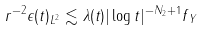<formula> <loc_0><loc_0><loc_500><loc_500>\| r ^ { - 2 } \epsilon ( t ) \| _ { L ^ { 2 } } \lesssim \lambda ( t ) | \log t | ^ { - N _ { 2 } + 1 } \| f \| _ { Y }</formula> 